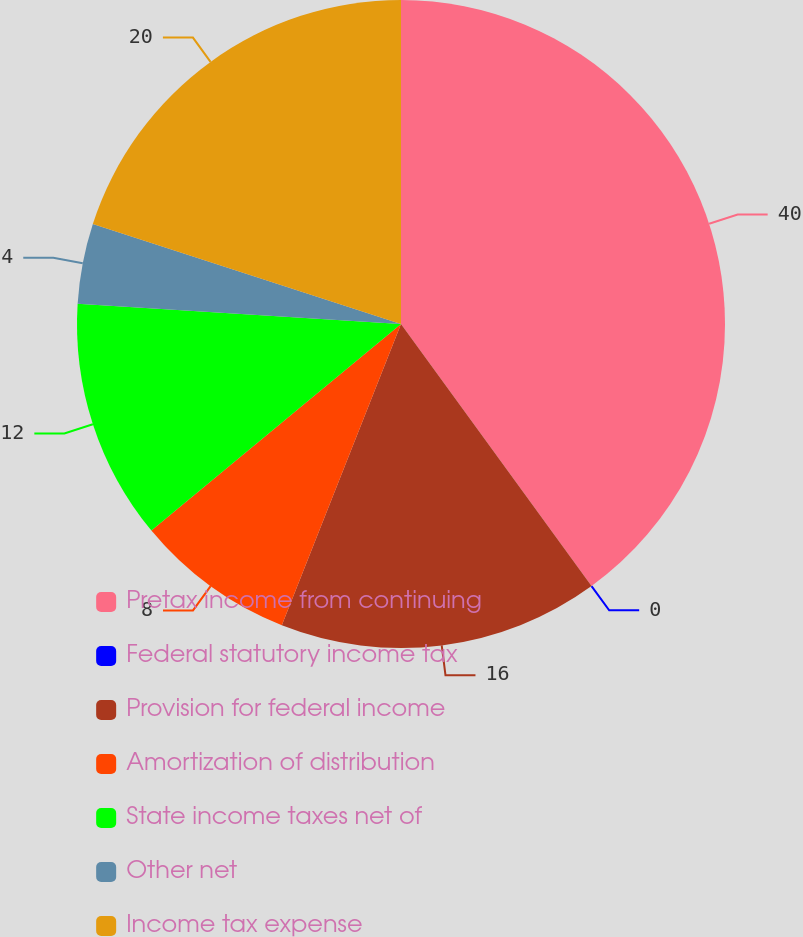Convert chart. <chart><loc_0><loc_0><loc_500><loc_500><pie_chart><fcel>Pretax income from continuing<fcel>Federal statutory income tax<fcel>Provision for federal income<fcel>Amortization of distribution<fcel>State income taxes net of<fcel>Other net<fcel>Income tax expense<nl><fcel>39.99%<fcel>0.0%<fcel>16.0%<fcel>8.0%<fcel>12.0%<fcel>4.0%<fcel>20.0%<nl></chart> 